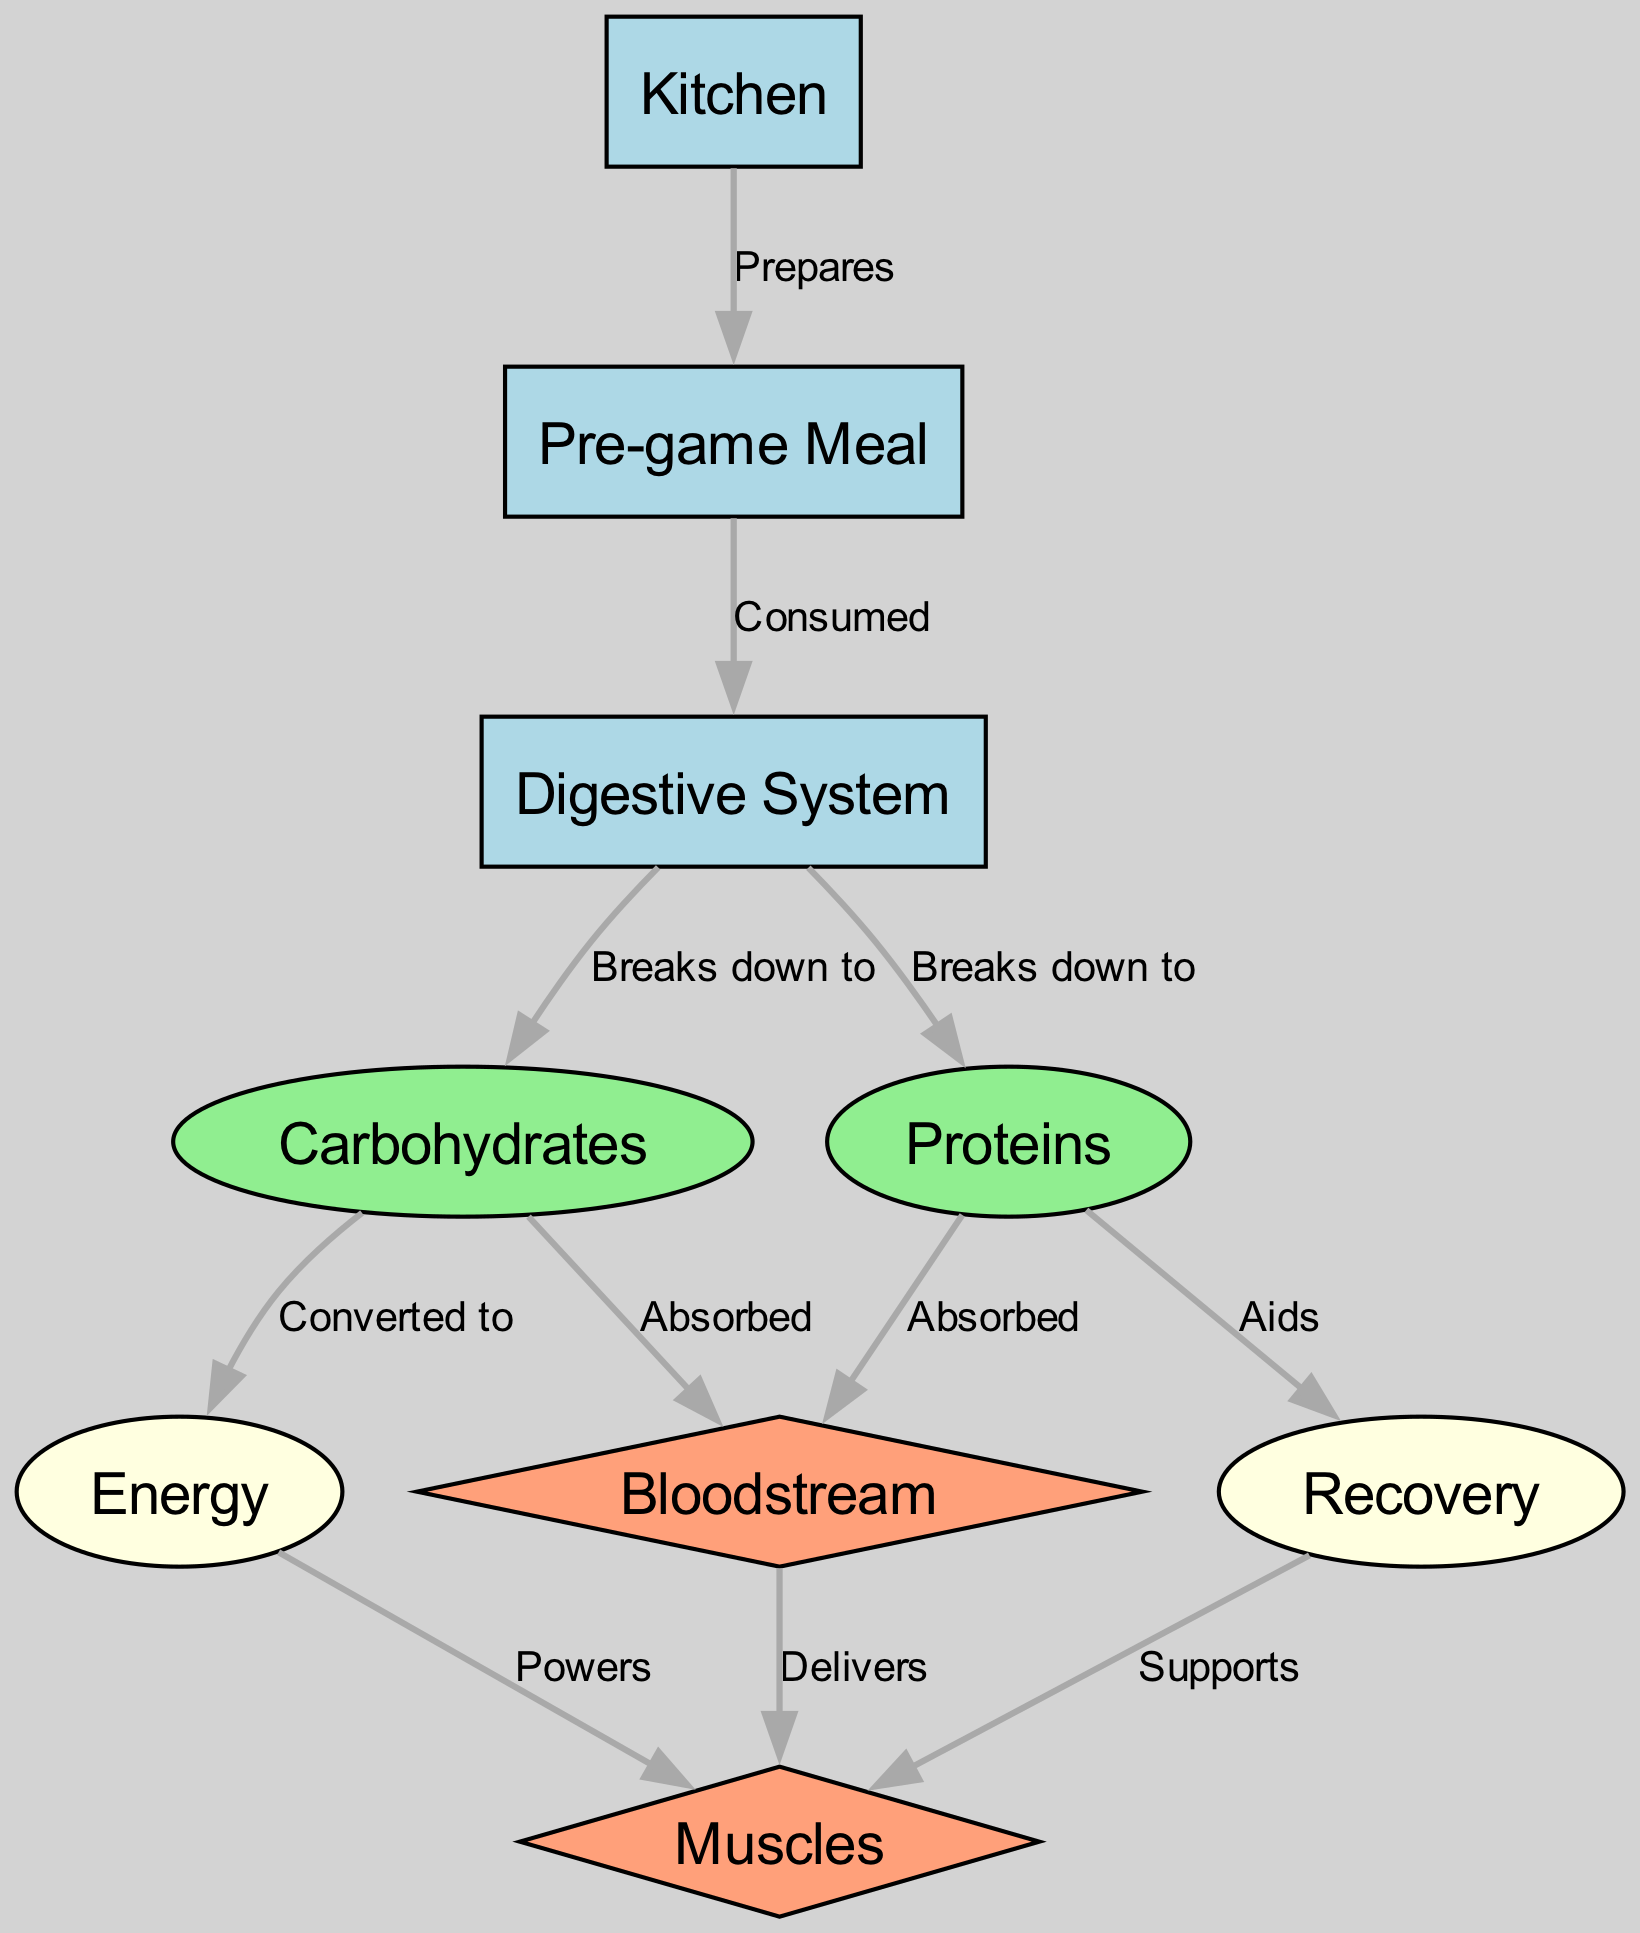What node represents where the meal preparation takes place? The diagram identifies the "Kitchen" node, which connects directly to the "Pre-game Meal" node, indicating that this is where the meal is prepared.
Answer: Kitchen How many nodes are there in total? By counting the entries in the "nodes" list from the data, we find there are 8 distinct nodes in the diagram.
Answer: 8 What relationship connects "Digestive System" to "Carbohydrates"? The edge labeled "Breaks down to" connects the "Digestive System" node to the "Carbohydrates" node, indicating that during digestion, carbohydrates are produced.
Answer: Breaks down to Which node aids in muscle recovery? The edge reads "Aids" from the "Proteins" node to the "Recovery" node, making it clear that proteins support muscle recovery.
Answer: Proteins What is the relationship between "Carbohydrates" and "Energy"? The diagram illustrates that "Carbohydrates" are "Converted to" "Energy," highlighting the process of energy production from carbohydrates.
Answer: Converted to How does energy impact the muscles? The relationship labeled "Powers" utilizes the edge leading from "Energy" to "Muscles," showing that energy is used to power muscle activity.
Answer: Powers Which substance is absorbed directly into the bloodstream from the digestive system? The diagram indicates that both "Carbohydrates" and "Proteins" are absorbed into the "Bloodstream," showing their importance in nutrient delivery.
Answer: Bloodstream What strengthens the muscle support in the diagram? There is a connection labeled "Supports" from the "Recovery" node to the "Muscles," demonstrating that recovery processes enhance muscle support.
Answer: Supports 